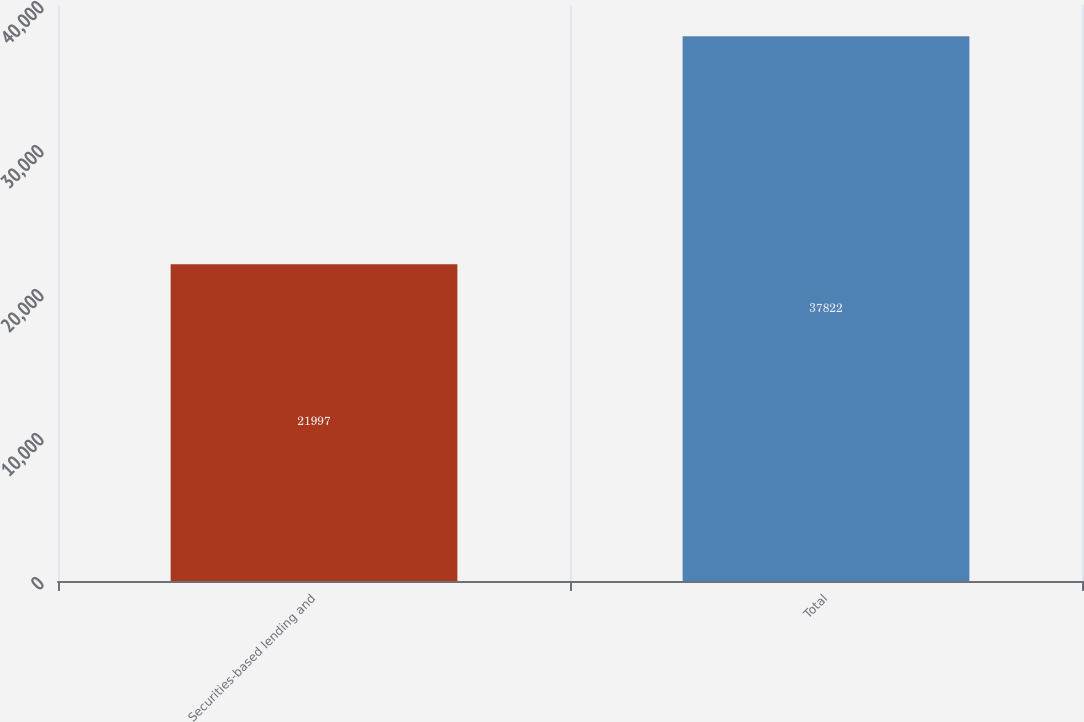Convert chart to OTSL. <chart><loc_0><loc_0><loc_500><loc_500><bar_chart><fcel>Securities-based lending and<fcel>Total<nl><fcel>21997<fcel>37822<nl></chart> 